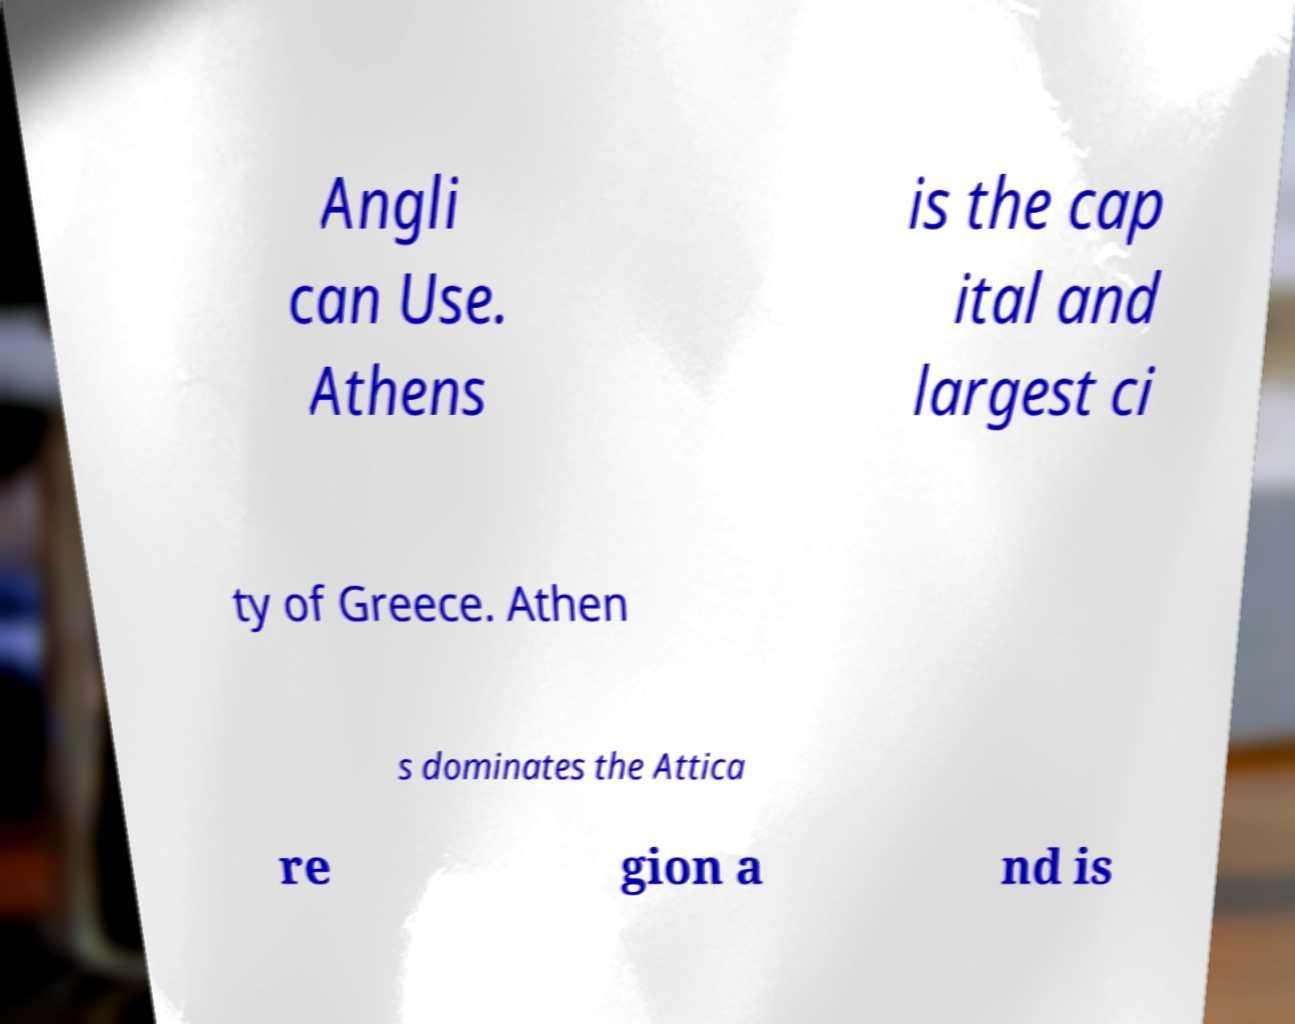I need the written content from this picture converted into text. Can you do that? Angli can Use. Athens is the cap ital and largest ci ty of Greece. Athen s dominates the Attica re gion a nd is 